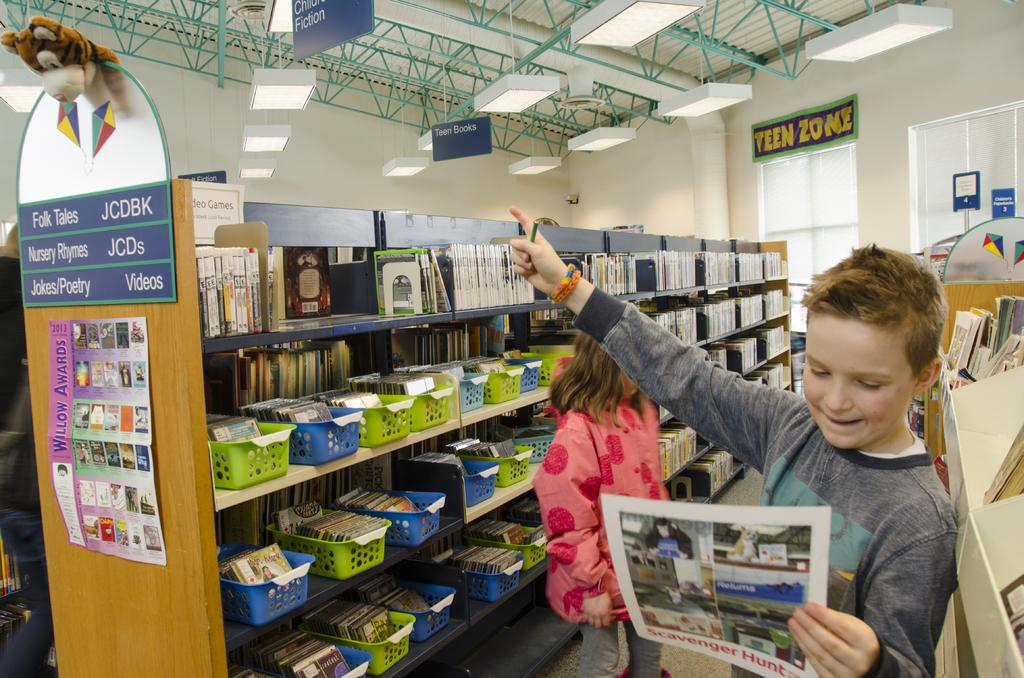<image>
Summarize the visual content of the image. A boy pointing up with a sign that says "Teen Zone" on it behind  him. 